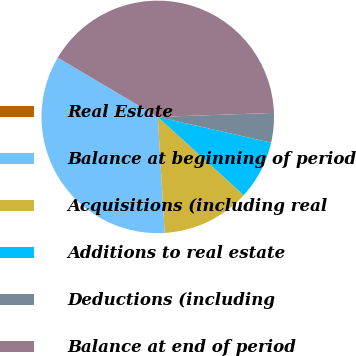Convert chart to OTSL. <chart><loc_0><loc_0><loc_500><loc_500><pie_chart><fcel>Real Estate<fcel>Balance at beginning of period<fcel>Acquisitions (including real<fcel>Additions to real estate<fcel>Deductions (including<fcel>Balance at end of period<nl><fcel>0.01%<fcel>34.45%<fcel>12.29%<fcel>8.2%<fcel>4.1%<fcel>40.95%<nl></chart> 